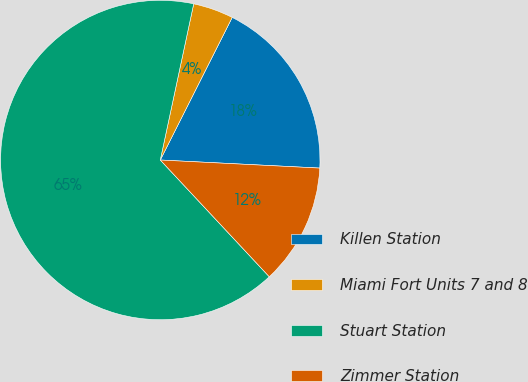<chart> <loc_0><loc_0><loc_500><loc_500><pie_chart><fcel>Killen Station<fcel>Miami Fort Units 7 and 8<fcel>Stuart Station<fcel>Zimmer Station<nl><fcel>18.37%<fcel>4.08%<fcel>65.31%<fcel>12.24%<nl></chart> 